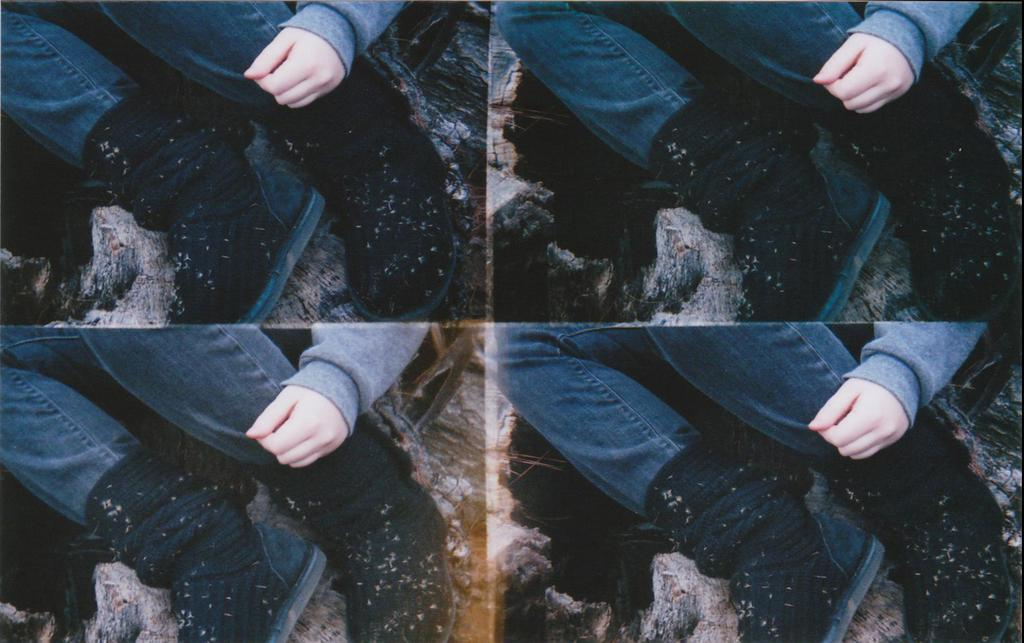What is the main subject of the image? The main subject of the image is a person, as depicted in four collage photos. What type of clothing is the person wearing? The person is wearing jeans. What type of footwear is the person wearing? The person is wearing black color shoes. Can you see any feathers on the person's clothing in the image? No, there are no feathers visible on the person's clothing in the image. Is the person in the image at an airport? The provided facts do not mention any airport or travel-related context, so it cannot be determined from the image. 